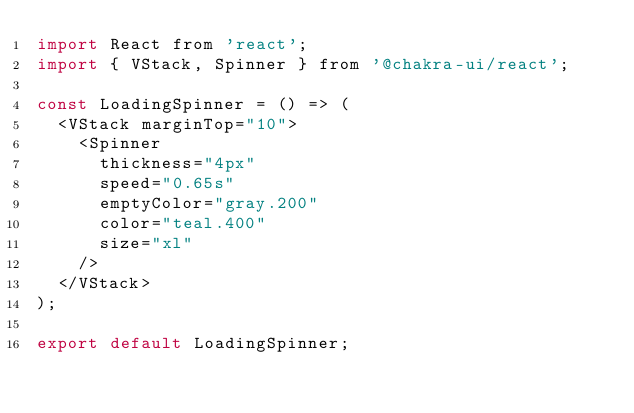<code> <loc_0><loc_0><loc_500><loc_500><_JavaScript_>import React from 'react';
import { VStack, Spinner } from '@chakra-ui/react';

const LoadingSpinner = () => (
  <VStack marginTop="10">
    <Spinner
      thickness="4px"
      speed="0.65s"
      emptyColor="gray.200"
      color="teal.400"
      size="xl"
    />
  </VStack>
);

export default LoadingSpinner;
</code> 